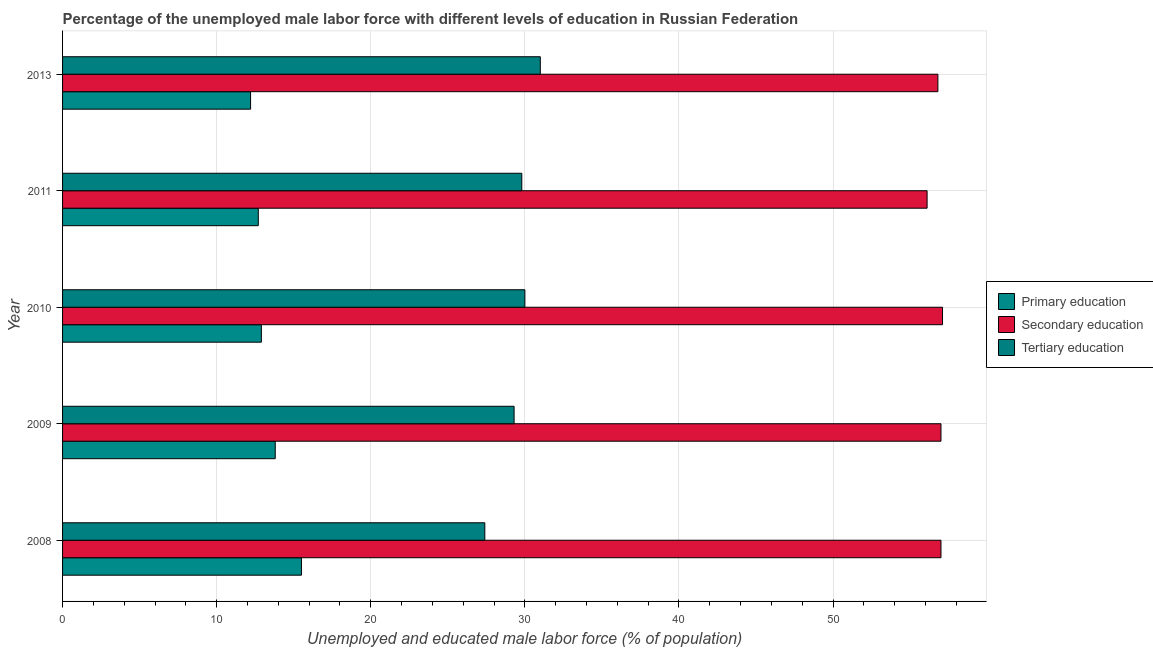Are the number of bars per tick equal to the number of legend labels?
Ensure brevity in your answer.  Yes. Are the number of bars on each tick of the Y-axis equal?
Provide a succinct answer. Yes. How many bars are there on the 2nd tick from the top?
Offer a very short reply. 3. What is the label of the 3rd group of bars from the top?
Give a very brief answer. 2010. Across all years, what is the maximum percentage of male labor force who received tertiary education?
Give a very brief answer. 31. Across all years, what is the minimum percentage of male labor force who received secondary education?
Make the answer very short. 56.1. In which year was the percentage of male labor force who received tertiary education minimum?
Your answer should be compact. 2008. What is the total percentage of male labor force who received secondary education in the graph?
Provide a short and direct response. 284. What is the difference between the percentage of male labor force who received primary education in 2008 and that in 2013?
Give a very brief answer. 3.3. What is the difference between the percentage of male labor force who received tertiary education in 2008 and the percentage of male labor force who received secondary education in 2011?
Ensure brevity in your answer.  -28.7. What is the average percentage of male labor force who received secondary education per year?
Provide a succinct answer. 56.8. What is the ratio of the percentage of male labor force who received secondary education in 2010 to that in 2011?
Provide a short and direct response. 1.02. Is the percentage of male labor force who received tertiary education in 2009 less than that in 2011?
Offer a very short reply. Yes. What is the difference between the highest and the lowest percentage of male labor force who received secondary education?
Make the answer very short. 1. In how many years, is the percentage of male labor force who received tertiary education greater than the average percentage of male labor force who received tertiary education taken over all years?
Your response must be concise. 3. Is the sum of the percentage of male labor force who received primary education in 2008 and 2011 greater than the maximum percentage of male labor force who received tertiary education across all years?
Your answer should be very brief. No. What does the 2nd bar from the top in 2009 represents?
Provide a short and direct response. Secondary education. What does the 3rd bar from the bottom in 2008 represents?
Ensure brevity in your answer.  Tertiary education. How many bars are there?
Provide a succinct answer. 15. Are all the bars in the graph horizontal?
Offer a terse response. Yes. Are the values on the major ticks of X-axis written in scientific E-notation?
Offer a terse response. No. Does the graph contain any zero values?
Make the answer very short. No. Does the graph contain grids?
Give a very brief answer. Yes. How are the legend labels stacked?
Provide a short and direct response. Vertical. What is the title of the graph?
Your answer should be very brief. Percentage of the unemployed male labor force with different levels of education in Russian Federation. Does "Ages 20-50" appear as one of the legend labels in the graph?
Offer a very short reply. No. What is the label or title of the X-axis?
Ensure brevity in your answer.  Unemployed and educated male labor force (% of population). What is the Unemployed and educated male labor force (% of population) in Primary education in 2008?
Ensure brevity in your answer.  15.5. What is the Unemployed and educated male labor force (% of population) in Secondary education in 2008?
Your response must be concise. 57. What is the Unemployed and educated male labor force (% of population) of Tertiary education in 2008?
Ensure brevity in your answer.  27.4. What is the Unemployed and educated male labor force (% of population) in Primary education in 2009?
Ensure brevity in your answer.  13.8. What is the Unemployed and educated male labor force (% of population) in Secondary education in 2009?
Offer a terse response. 57. What is the Unemployed and educated male labor force (% of population) in Tertiary education in 2009?
Your answer should be compact. 29.3. What is the Unemployed and educated male labor force (% of population) of Primary education in 2010?
Make the answer very short. 12.9. What is the Unemployed and educated male labor force (% of population) in Secondary education in 2010?
Keep it short and to the point. 57.1. What is the Unemployed and educated male labor force (% of population) of Tertiary education in 2010?
Ensure brevity in your answer.  30. What is the Unemployed and educated male labor force (% of population) of Primary education in 2011?
Ensure brevity in your answer.  12.7. What is the Unemployed and educated male labor force (% of population) of Secondary education in 2011?
Ensure brevity in your answer.  56.1. What is the Unemployed and educated male labor force (% of population) of Tertiary education in 2011?
Provide a short and direct response. 29.8. What is the Unemployed and educated male labor force (% of population) of Primary education in 2013?
Give a very brief answer. 12.2. What is the Unemployed and educated male labor force (% of population) of Secondary education in 2013?
Offer a very short reply. 56.8. Across all years, what is the maximum Unemployed and educated male labor force (% of population) in Primary education?
Your response must be concise. 15.5. Across all years, what is the maximum Unemployed and educated male labor force (% of population) of Secondary education?
Offer a very short reply. 57.1. Across all years, what is the maximum Unemployed and educated male labor force (% of population) in Tertiary education?
Ensure brevity in your answer.  31. Across all years, what is the minimum Unemployed and educated male labor force (% of population) in Primary education?
Your answer should be compact. 12.2. Across all years, what is the minimum Unemployed and educated male labor force (% of population) in Secondary education?
Your response must be concise. 56.1. Across all years, what is the minimum Unemployed and educated male labor force (% of population) of Tertiary education?
Your answer should be compact. 27.4. What is the total Unemployed and educated male labor force (% of population) in Primary education in the graph?
Provide a short and direct response. 67.1. What is the total Unemployed and educated male labor force (% of population) of Secondary education in the graph?
Your response must be concise. 284. What is the total Unemployed and educated male labor force (% of population) in Tertiary education in the graph?
Make the answer very short. 147.5. What is the difference between the Unemployed and educated male labor force (% of population) in Tertiary education in 2008 and that in 2009?
Offer a terse response. -1.9. What is the difference between the Unemployed and educated male labor force (% of population) in Tertiary education in 2008 and that in 2010?
Make the answer very short. -2.6. What is the difference between the Unemployed and educated male labor force (% of population) in Tertiary education in 2008 and that in 2011?
Provide a short and direct response. -2.4. What is the difference between the Unemployed and educated male labor force (% of population) in Primary education in 2008 and that in 2013?
Ensure brevity in your answer.  3.3. What is the difference between the Unemployed and educated male labor force (% of population) of Secondary education in 2008 and that in 2013?
Provide a short and direct response. 0.2. What is the difference between the Unemployed and educated male labor force (% of population) in Secondary education in 2009 and that in 2010?
Provide a succinct answer. -0.1. What is the difference between the Unemployed and educated male labor force (% of population) of Tertiary education in 2009 and that in 2010?
Your answer should be compact. -0.7. What is the difference between the Unemployed and educated male labor force (% of population) in Primary education in 2009 and that in 2011?
Offer a terse response. 1.1. What is the difference between the Unemployed and educated male labor force (% of population) in Secondary education in 2009 and that in 2011?
Make the answer very short. 0.9. What is the difference between the Unemployed and educated male labor force (% of population) of Tertiary education in 2009 and that in 2013?
Your answer should be compact. -1.7. What is the difference between the Unemployed and educated male labor force (% of population) in Tertiary education in 2010 and that in 2011?
Your answer should be compact. 0.2. What is the difference between the Unemployed and educated male labor force (% of population) in Primary education in 2010 and that in 2013?
Your answer should be compact. 0.7. What is the difference between the Unemployed and educated male labor force (% of population) in Tertiary education in 2010 and that in 2013?
Your response must be concise. -1. What is the difference between the Unemployed and educated male labor force (% of population) of Secondary education in 2011 and that in 2013?
Keep it short and to the point. -0.7. What is the difference between the Unemployed and educated male labor force (% of population) in Tertiary education in 2011 and that in 2013?
Keep it short and to the point. -1.2. What is the difference between the Unemployed and educated male labor force (% of population) of Primary education in 2008 and the Unemployed and educated male labor force (% of population) of Secondary education in 2009?
Offer a terse response. -41.5. What is the difference between the Unemployed and educated male labor force (% of population) in Secondary education in 2008 and the Unemployed and educated male labor force (% of population) in Tertiary education in 2009?
Make the answer very short. 27.7. What is the difference between the Unemployed and educated male labor force (% of population) in Primary education in 2008 and the Unemployed and educated male labor force (% of population) in Secondary education in 2010?
Make the answer very short. -41.6. What is the difference between the Unemployed and educated male labor force (% of population) in Primary education in 2008 and the Unemployed and educated male labor force (% of population) in Tertiary education in 2010?
Ensure brevity in your answer.  -14.5. What is the difference between the Unemployed and educated male labor force (% of population) of Secondary education in 2008 and the Unemployed and educated male labor force (% of population) of Tertiary education in 2010?
Your answer should be compact. 27. What is the difference between the Unemployed and educated male labor force (% of population) in Primary education in 2008 and the Unemployed and educated male labor force (% of population) in Secondary education in 2011?
Make the answer very short. -40.6. What is the difference between the Unemployed and educated male labor force (% of population) in Primary education in 2008 and the Unemployed and educated male labor force (% of population) in Tertiary education in 2011?
Your answer should be compact. -14.3. What is the difference between the Unemployed and educated male labor force (% of population) in Secondary education in 2008 and the Unemployed and educated male labor force (% of population) in Tertiary education in 2011?
Ensure brevity in your answer.  27.2. What is the difference between the Unemployed and educated male labor force (% of population) in Primary education in 2008 and the Unemployed and educated male labor force (% of population) in Secondary education in 2013?
Ensure brevity in your answer.  -41.3. What is the difference between the Unemployed and educated male labor force (% of population) in Primary education in 2008 and the Unemployed and educated male labor force (% of population) in Tertiary education in 2013?
Your response must be concise. -15.5. What is the difference between the Unemployed and educated male labor force (% of population) in Secondary education in 2008 and the Unemployed and educated male labor force (% of population) in Tertiary education in 2013?
Make the answer very short. 26. What is the difference between the Unemployed and educated male labor force (% of population) in Primary education in 2009 and the Unemployed and educated male labor force (% of population) in Secondary education in 2010?
Your response must be concise. -43.3. What is the difference between the Unemployed and educated male labor force (% of population) of Primary education in 2009 and the Unemployed and educated male labor force (% of population) of Tertiary education in 2010?
Provide a short and direct response. -16.2. What is the difference between the Unemployed and educated male labor force (% of population) of Secondary education in 2009 and the Unemployed and educated male labor force (% of population) of Tertiary education in 2010?
Provide a succinct answer. 27. What is the difference between the Unemployed and educated male labor force (% of population) of Primary education in 2009 and the Unemployed and educated male labor force (% of population) of Secondary education in 2011?
Keep it short and to the point. -42.3. What is the difference between the Unemployed and educated male labor force (% of population) in Primary education in 2009 and the Unemployed and educated male labor force (% of population) in Tertiary education in 2011?
Your answer should be very brief. -16. What is the difference between the Unemployed and educated male labor force (% of population) in Secondary education in 2009 and the Unemployed and educated male labor force (% of population) in Tertiary education in 2011?
Offer a terse response. 27.2. What is the difference between the Unemployed and educated male labor force (% of population) of Primary education in 2009 and the Unemployed and educated male labor force (% of population) of Secondary education in 2013?
Provide a succinct answer. -43. What is the difference between the Unemployed and educated male labor force (% of population) in Primary education in 2009 and the Unemployed and educated male labor force (% of population) in Tertiary education in 2013?
Offer a very short reply. -17.2. What is the difference between the Unemployed and educated male labor force (% of population) of Primary education in 2010 and the Unemployed and educated male labor force (% of population) of Secondary education in 2011?
Give a very brief answer. -43.2. What is the difference between the Unemployed and educated male labor force (% of population) in Primary education in 2010 and the Unemployed and educated male labor force (% of population) in Tertiary education in 2011?
Your response must be concise. -16.9. What is the difference between the Unemployed and educated male labor force (% of population) of Secondary education in 2010 and the Unemployed and educated male labor force (% of population) of Tertiary education in 2011?
Your answer should be compact. 27.3. What is the difference between the Unemployed and educated male labor force (% of population) of Primary education in 2010 and the Unemployed and educated male labor force (% of population) of Secondary education in 2013?
Your answer should be compact. -43.9. What is the difference between the Unemployed and educated male labor force (% of population) of Primary education in 2010 and the Unemployed and educated male labor force (% of population) of Tertiary education in 2013?
Your answer should be compact. -18.1. What is the difference between the Unemployed and educated male labor force (% of population) in Secondary education in 2010 and the Unemployed and educated male labor force (% of population) in Tertiary education in 2013?
Give a very brief answer. 26.1. What is the difference between the Unemployed and educated male labor force (% of population) of Primary education in 2011 and the Unemployed and educated male labor force (% of population) of Secondary education in 2013?
Offer a very short reply. -44.1. What is the difference between the Unemployed and educated male labor force (% of population) in Primary education in 2011 and the Unemployed and educated male labor force (% of population) in Tertiary education in 2013?
Offer a terse response. -18.3. What is the difference between the Unemployed and educated male labor force (% of population) in Secondary education in 2011 and the Unemployed and educated male labor force (% of population) in Tertiary education in 2013?
Keep it short and to the point. 25.1. What is the average Unemployed and educated male labor force (% of population) in Primary education per year?
Make the answer very short. 13.42. What is the average Unemployed and educated male labor force (% of population) of Secondary education per year?
Your answer should be very brief. 56.8. What is the average Unemployed and educated male labor force (% of population) of Tertiary education per year?
Provide a short and direct response. 29.5. In the year 2008, what is the difference between the Unemployed and educated male labor force (% of population) of Primary education and Unemployed and educated male labor force (% of population) of Secondary education?
Provide a succinct answer. -41.5. In the year 2008, what is the difference between the Unemployed and educated male labor force (% of population) in Secondary education and Unemployed and educated male labor force (% of population) in Tertiary education?
Your response must be concise. 29.6. In the year 2009, what is the difference between the Unemployed and educated male labor force (% of population) in Primary education and Unemployed and educated male labor force (% of population) in Secondary education?
Your response must be concise. -43.2. In the year 2009, what is the difference between the Unemployed and educated male labor force (% of population) of Primary education and Unemployed and educated male labor force (% of population) of Tertiary education?
Offer a very short reply. -15.5. In the year 2009, what is the difference between the Unemployed and educated male labor force (% of population) of Secondary education and Unemployed and educated male labor force (% of population) of Tertiary education?
Offer a very short reply. 27.7. In the year 2010, what is the difference between the Unemployed and educated male labor force (% of population) in Primary education and Unemployed and educated male labor force (% of population) in Secondary education?
Offer a terse response. -44.2. In the year 2010, what is the difference between the Unemployed and educated male labor force (% of population) of Primary education and Unemployed and educated male labor force (% of population) of Tertiary education?
Offer a terse response. -17.1. In the year 2010, what is the difference between the Unemployed and educated male labor force (% of population) of Secondary education and Unemployed and educated male labor force (% of population) of Tertiary education?
Keep it short and to the point. 27.1. In the year 2011, what is the difference between the Unemployed and educated male labor force (% of population) in Primary education and Unemployed and educated male labor force (% of population) in Secondary education?
Your answer should be compact. -43.4. In the year 2011, what is the difference between the Unemployed and educated male labor force (% of population) of Primary education and Unemployed and educated male labor force (% of population) of Tertiary education?
Provide a succinct answer. -17.1. In the year 2011, what is the difference between the Unemployed and educated male labor force (% of population) of Secondary education and Unemployed and educated male labor force (% of population) of Tertiary education?
Offer a terse response. 26.3. In the year 2013, what is the difference between the Unemployed and educated male labor force (% of population) in Primary education and Unemployed and educated male labor force (% of population) in Secondary education?
Provide a succinct answer. -44.6. In the year 2013, what is the difference between the Unemployed and educated male labor force (% of population) of Primary education and Unemployed and educated male labor force (% of population) of Tertiary education?
Ensure brevity in your answer.  -18.8. In the year 2013, what is the difference between the Unemployed and educated male labor force (% of population) of Secondary education and Unemployed and educated male labor force (% of population) of Tertiary education?
Ensure brevity in your answer.  25.8. What is the ratio of the Unemployed and educated male labor force (% of population) of Primary education in 2008 to that in 2009?
Offer a terse response. 1.12. What is the ratio of the Unemployed and educated male labor force (% of population) in Tertiary education in 2008 to that in 2009?
Provide a short and direct response. 0.94. What is the ratio of the Unemployed and educated male labor force (% of population) of Primary education in 2008 to that in 2010?
Offer a very short reply. 1.2. What is the ratio of the Unemployed and educated male labor force (% of population) of Secondary education in 2008 to that in 2010?
Make the answer very short. 1. What is the ratio of the Unemployed and educated male labor force (% of population) in Tertiary education in 2008 to that in 2010?
Your response must be concise. 0.91. What is the ratio of the Unemployed and educated male labor force (% of population) of Primary education in 2008 to that in 2011?
Provide a short and direct response. 1.22. What is the ratio of the Unemployed and educated male labor force (% of population) of Secondary education in 2008 to that in 2011?
Offer a very short reply. 1.02. What is the ratio of the Unemployed and educated male labor force (% of population) in Tertiary education in 2008 to that in 2011?
Offer a very short reply. 0.92. What is the ratio of the Unemployed and educated male labor force (% of population) in Primary education in 2008 to that in 2013?
Your answer should be very brief. 1.27. What is the ratio of the Unemployed and educated male labor force (% of population) of Tertiary education in 2008 to that in 2013?
Give a very brief answer. 0.88. What is the ratio of the Unemployed and educated male labor force (% of population) of Primary education in 2009 to that in 2010?
Make the answer very short. 1.07. What is the ratio of the Unemployed and educated male labor force (% of population) in Secondary education in 2009 to that in 2010?
Ensure brevity in your answer.  1. What is the ratio of the Unemployed and educated male labor force (% of population) of Tertiary education in 2009 to that in 2010?
Your response must be concise. 0.98. What is the ratio of the Unemployed and educated male labor force (% of population) of Primary education in 2009 to that in 2011?
Your answer should be compact. 1.09. What is the ratio of the Unemployed and educated male labor force (% of population) in Tertiary education in 2009 to that in 2011?
Keep it short and to the point. 0.98. What is the ratio of the Unemployed and educated male labor force (% of population) in Primary education in 2009 to that in 2013?
Give a very brief answer. 1.13. What is the ratio of the Unemployed and educated male labor force (% of population) in Secondary education in 2009 to that in 2013?
Give a very brief answer. 1. What is the ratio of the Unemployed and educated male labor force (% of population) of Tertiary education in 2009 to that in 2013?
Offer a terse response. 0.95. What is the ratio of the Unemployed and educated male labor force (% of population) of Primary education in 2010 to that in 2011?
Give a very brief answer. 1.02. What is the ratio of the Unemployed and educated male labor force (% of population) of Secondary education in 2010 to that in 2011?
Provide a succinct answer. 1.02. What is the ratio of the Unemployed and educated male labor force (% of population) of Tertiary education in 2010 to that in 2011?
Your response must be concise. 1.01. What is the ratio of the Unemployed and educated male labor force (% of population) in Primary education in 2010 to that in 2013?
Your answer should be compact. 1.06. What is the ratio of the Unemployed and educated male labor force (% of population) in Tertiary education in 2010 to that in 2013?
Your answer should be compact. 0.97. What is the ratio of the Unemployed and educated male labor force (% of population) of Primary education in 2011 to that in 2013?
Provide a short and direct response. 1.04. What is the ratio of the Unemployed and educated male labor force (% of population) in Secondary education in 2011 to that in 2013?
Your response must be concise. 0.99. What is the ratio of the Unemployed and educated male labor force (% of population) of Tertiary education in 2011 to that in 2013?
Keep it short and to the point. 0.96. What is the difference between the highest and the second highest Unemployed and educated male labor force (% of population) in Primary education?
Your answer should be compact. 1.7. What is the difference between the highest and the lowest Unemployed and educated male labor force (% of population) of Primary education?
Offer a terse response. 3.3. 